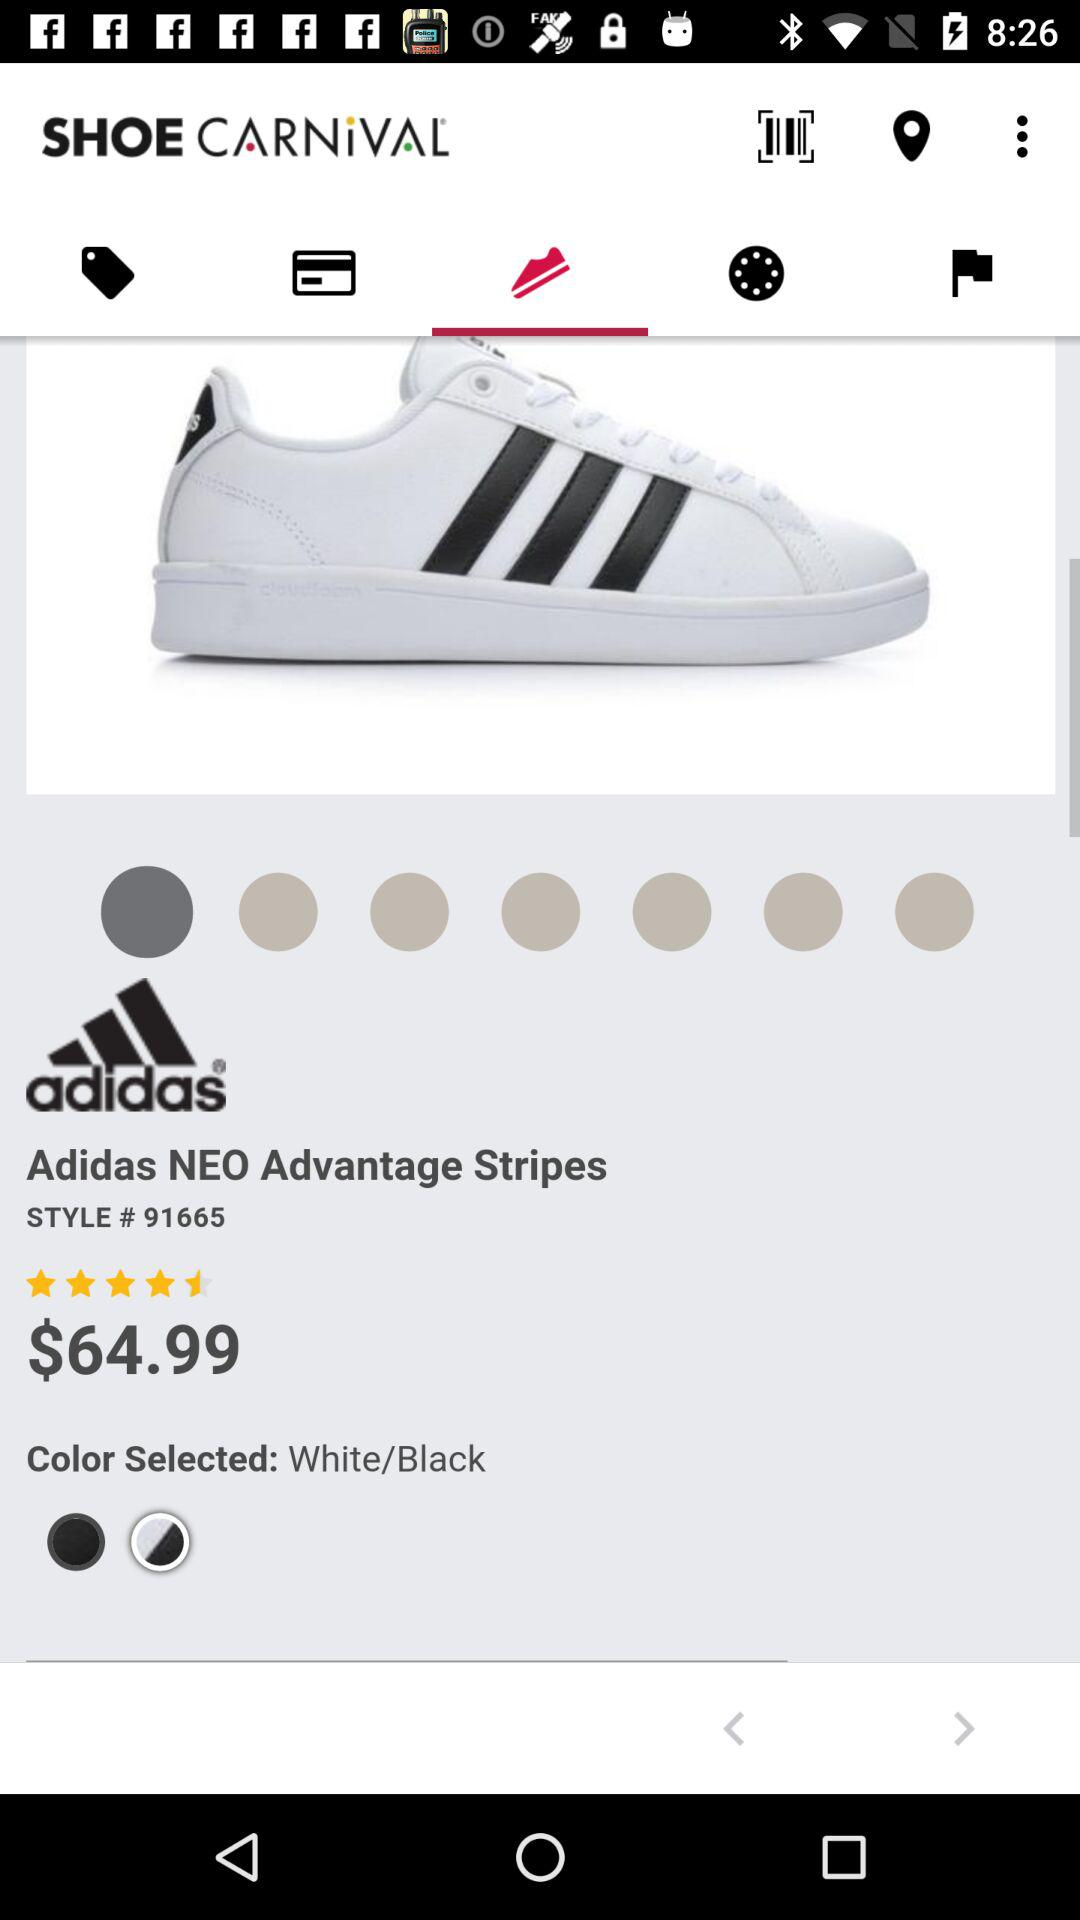What is the style code of the Adidas NEO Advantage stripes? The style code is 91665. 